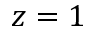<formula> <loc_0><loc_0><loc_500><loc_500>z = 1</formula> 